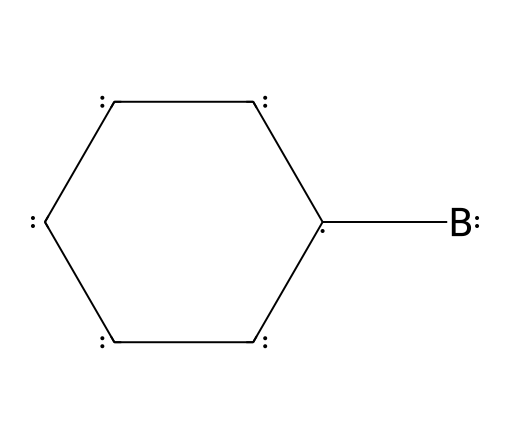What is the central atom in this structure? In the provided structure, the boron atom (B) is the central atom connected to carbon atoms (C), making it the defining element of the borane compound.
Answer: boron How many carbon atoms are present in this chemical structure? The SMILES representation shows a cyclic structure made up of six vertices, all of which are carbon atoms, indicating that there are six carbon atoms in total.
Answer: six What type of bond is primarily formed between the carbon atoms in this structure? In a closed carbon ring as depicted, the connection between the carbon atoms is predominantly covalent bonding, where electrons are shared among them.
Answer: covalent What unique feature of boranes does this structure represent? Boranes are known for having a unique ability to form clusters with low coordination number; here, the boron is bonded into a graphitic lattice alongside carbons, indicating a shared electron cloud for conductivity.
Answer: conductivity How many total atoms are in this chemical structure? The structure includes six carbon atoms and one boron atom, totaling seven atoms when added together.
Answer: seven What is the significance of boron in electric vehicle batteries? Boron enhances electron mobility and provides efficient energy transfer in materials like graphene, making it crucial for improving battery performance in electric vehicles.
Answer: energy transfer Which type of chemical compound is indicated by the presence of boron and carbon in this structure? The combination of boron and carbon forms a class of compounds known as boranes, particularly in this case as a structured carbon-boron hybrid system.
Answer: boranes 